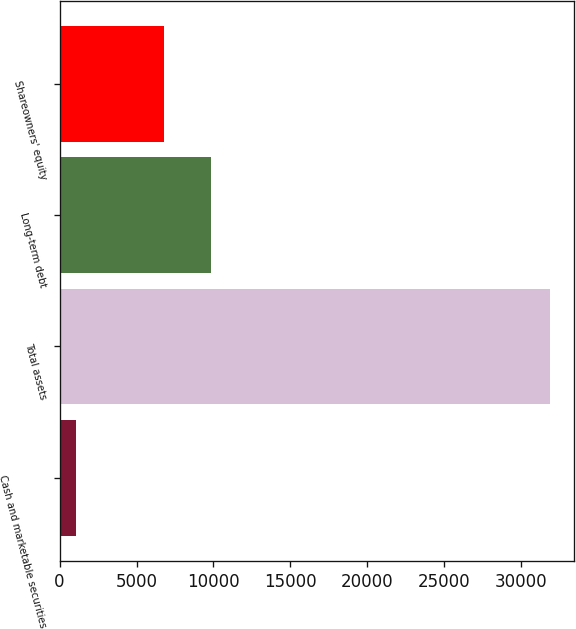Convert chart. <chart><loc_0><loc_0><loc_500><loc_500><bar_chart><fcel>Cash and marketable securities<fcel>Total assets<fcel>Long-term debt<fcel>Shareowners' equity<nl><fcel>1049<fcel>31879<fcel>9863<fcel>6780<nl></chart> 